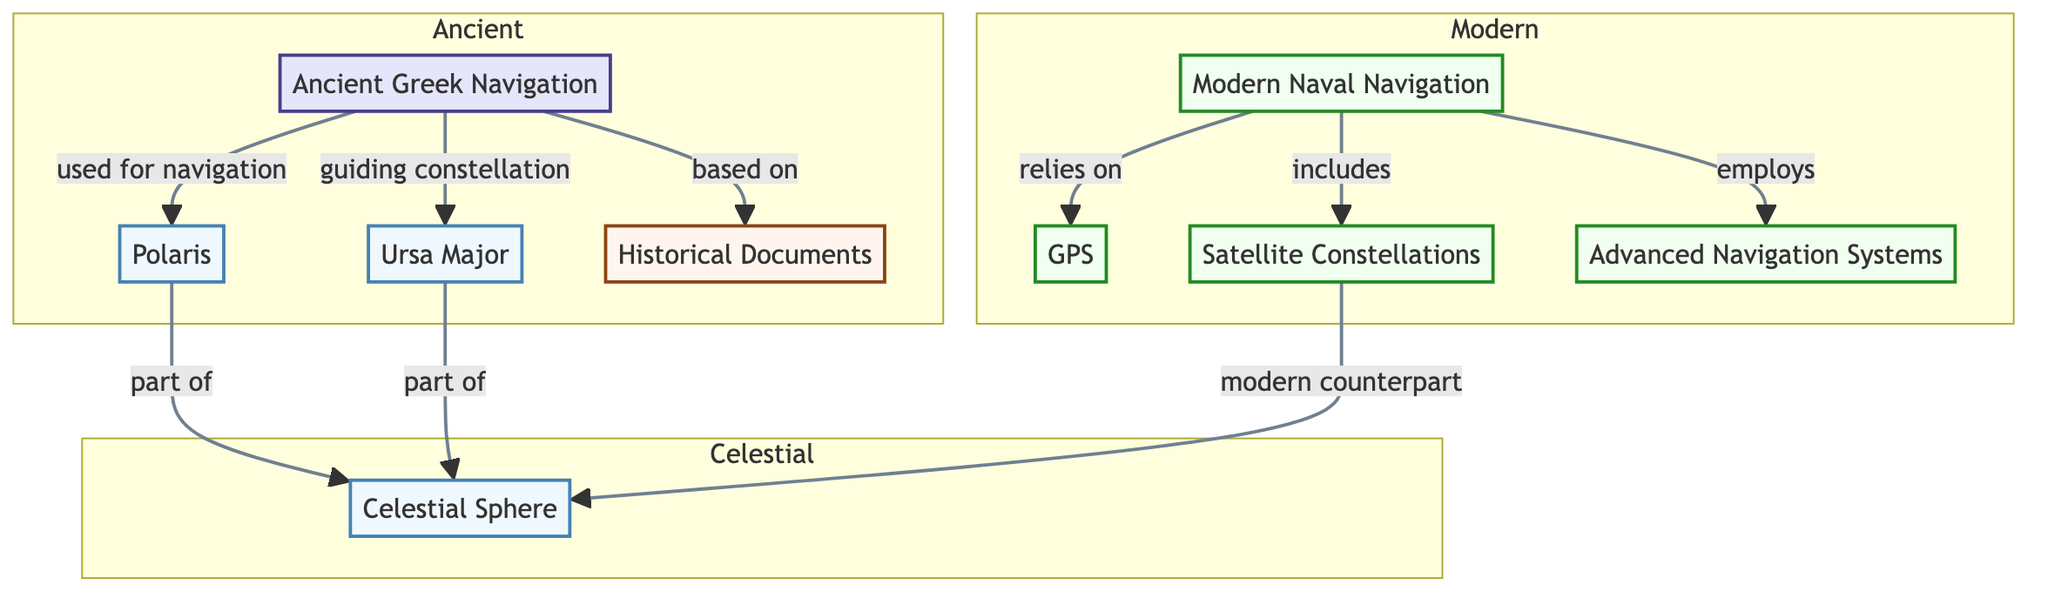What is the guiding constellation used in Ancient Greek Navigation? The diagram indicates that the guiding constellation used in Ancient Greek Navigation is Ursa Major. This can be found by tracing the link from Ancient Greek Navigation (AGN) to the guiding constellation (UMA).
Answer: Ursa Major How many main techniques for navigation are depicted in the diagram? The diagram shows two main techniques for navigation: Ancient Greek Navigation and Modern Naval Navigation. This can be analyzed by counting the major nodes AGN and MNN, each representing a navigation technique.
Answer: 2 What is the modern counterpart of the Celestial Sphere? The diagram connects modern navigation (MNN) to satellite constellations (SAT), indicating that satellite constellations are the modern counterpart of the Celestial Sphere (CSP).
Answer: Satellite Constellations Which star is exclusively associated with Ancient Greek Navigation? The diagram shows a direct relationship where Polaris (POL) is used specifically for navigation in Ancient Greek Navigation. There are no other exclusive stars listed under Ancient Greek Navigation, making Polaris the answer.
Answer: Polaris What is the relationship between Advanced Navigation Systems and Modern Naval Navigation? The diagram establishes a link from Modern Naval Navigation (MNN) to Advanced Navigation Systems (ANS), indicating that Advanced Navigation Systems are employed within the framework of Modern Naval Navigation. This shows a direct operational relationship.
Answer: Employs What celestial body is part of the Celestial Sphere in both ancient and modern techniques? Both Polaris (POL) and Ursa Major (UMA) are designated as parts of the Celestial Sphere (CSP) in the diagram. This can be deduced by observing the connection from both stars to the CSP node.
Answer: Part of Celestial Sphere How does Ancient Greek Navigation connect to historical documentation? According to the diagram, Ancient Greek Navigation is based on Historical Documents (HIS). This connection demonstrates a foundational relationship where ancient navigation knowledge is derived from documented histories.
Answer: Based on What are the three components used in modern naval navigation besides GPS? The diagram lists two additional components besides GPS within Modern Naval Navigation: Satellite Constellations (SAT) and Advanced Navigation Systems (ANS). These items are connected directly to the modern navigation node, summarizing their role in contemporary techniques.
Answer: Satellite Constellations, Advanced Navigation Systems 